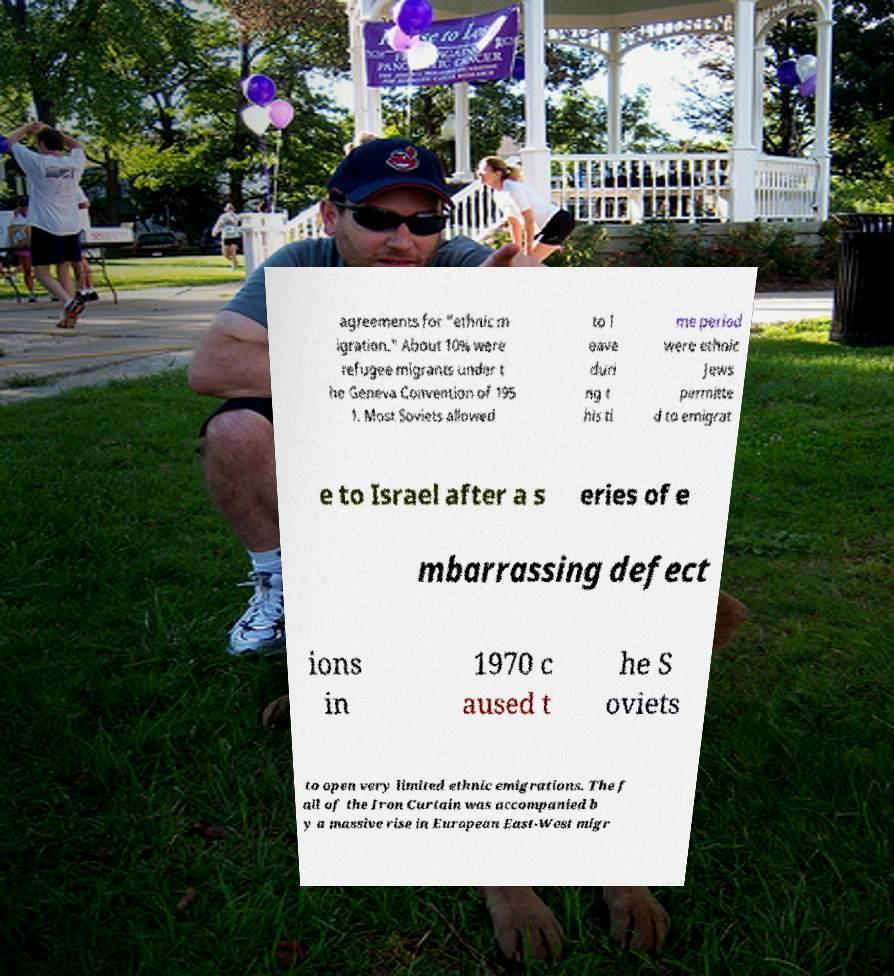I need the written content from this picture converted into text. Can you do that? agreements for "ethnic m igration." About 10% were refugee migrants under t he Geneva Convention of 195 1. Most Soviets allowed to l eave duri ng t his ti me period were ethnic Jews permitte d to emigrat e to Israel after a s eries of e mbarrassing defect ions in 1970 c aused t he S oviets to open very limited ethnic emigrations. The f all of the Iron Curtain was accompanied b y a massive rise in European East-West migr 